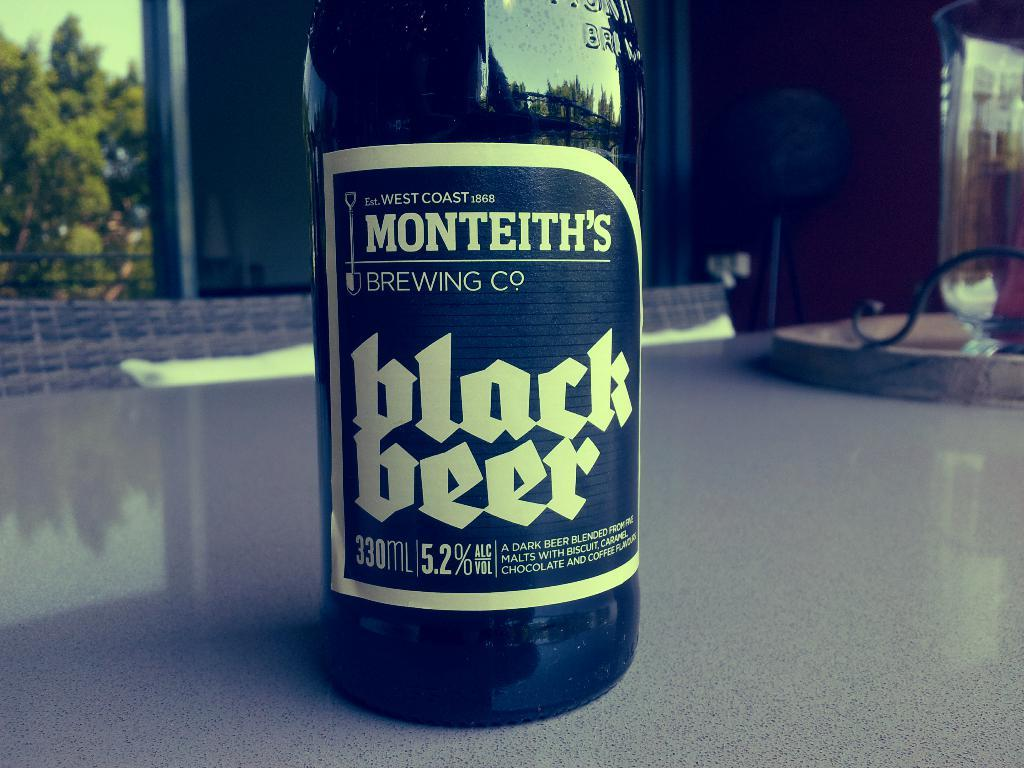<image>
Render a clear and concise summary of the photo. A bottle of black beer has the date 1868 on the top of the label. 